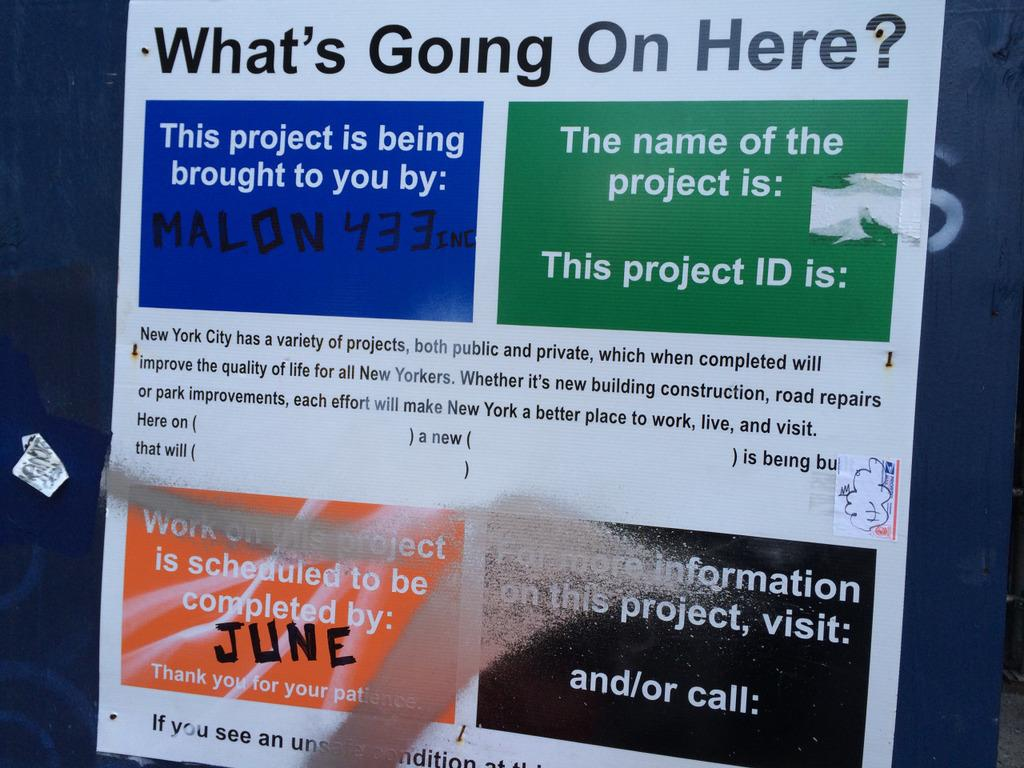<image>
Share a concise interpretation of the image provided. An information poster that is explaining what's going on here 